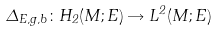Convert formula to latex. <formula><loc_0><loc_0><loc_500><loc_500>\Delta _ { E , g , b } \colon H _ { 2 } ( M ; E ) \rightarrow L ^ { 2 } ( M ; E )</formula> 